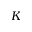<formula> <loc_0><loc_0><loc_500><loc_500>K</formula> 